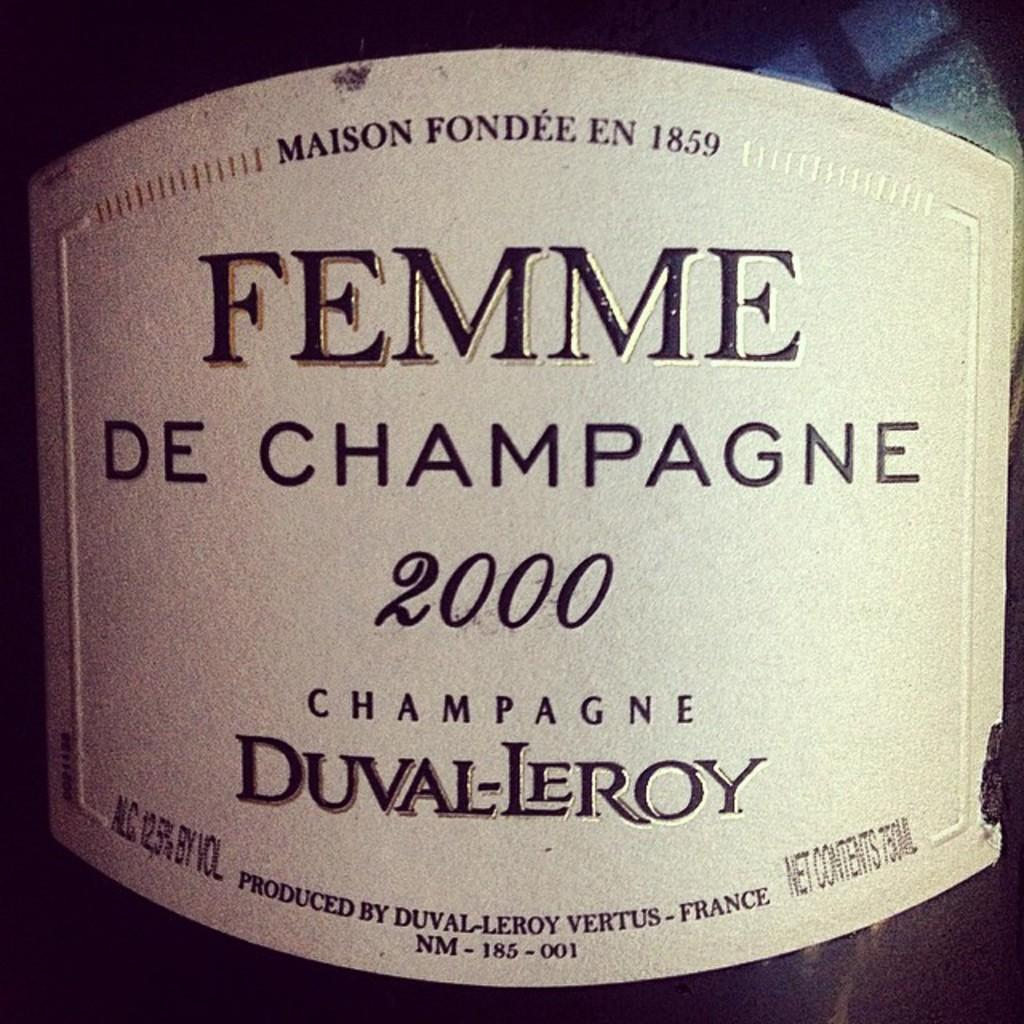<image>
Create a compact narrative representing the image presented. The bottle of Femme de champagne was produced in France. 